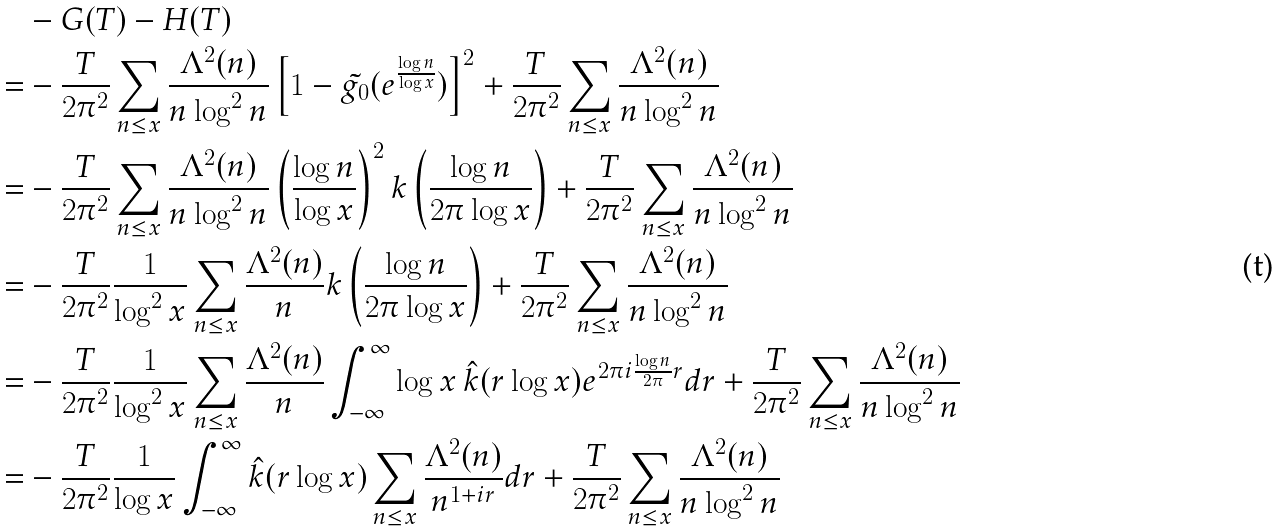<formula> <loc_0><loc_0><loc_500><loc_500>& - G ( T ) - H ( T ) \\ = & - \frac { T } { 2 \pi ^ { 2 } } \sum _ { n \leq x } \frac { \Lambda ^ { 2 } ( n ) } { n \log ^ { 2 } n } \left [ 1 - \tilde { g _ { 0 } } ( e ^ { \frac { \log n } { \log x } } ) \right ] ^ { 2 } + \frac { T } { 2 \pi ^ { 2 } } \sum _ { n \leq x } \frac { \Lambda ^ { 2 } ( n ) } { n \log ^ { 2 } n } \\ = & - \frac { T } { 2 \pi ^ { 2 } } \sum _ { n \leq x } \frac { \Lambda ^ { 2 } ( n ) } { n \log ^ { 2 } n } \left ( \frac { \log n } { \log x } \right ) ^ { 2 } k \left ( \frac { \log n } { 2 \pi \log x } \right ) + \frac { T } { 2 \pi ^ { 2 } } \sum _ { n \leq x } \frac { \Lambda ^ { 2 } ( n ) } { n \log ^ { 2 } n } \\ = & - \frac { T } { 2 \pi ^ { 2 } } \frac { 1 } { \log ^ { 2 } x } \sum _ { n \leq x } \frac { \Lambda ^ { 2 } ( n ) } { n } k \left ( \frac { \log n } { 2 \pi \log x } \right ) + \frac { T } { 2 \pi ^ { 2 } } \sum _ { n \leq x } \frac { \Lambda ^ { 2 } ( n ) } { n \log ^ { 2 } n } \\ = & - \frac { T } { 2 \pi ^ { 2 } } \frac { 1 } { \log ^ { 2 } x } \sum _ { n \leq x } \frac { \Lambda ^ { 2 } ( n ) } { n } \int _ { - \infty } ^ { \infty } \log x \, \hat { k } ( r \log x ) e ^ { 2 \pi i \frac { \log n } { 2 \pi } r } d r + \frac { T } { 2 \pi ^ { 2 } } \sum _ { n \leq x } \frac { \Lambda ^ { 2 } ( n ) } { n \log ^ { 2 } n } \\ = & - \frac { T } { 2 \pi ^ { 2 } } \frac { 1 } { \log x } \int _ { - \infty } ^ { \infty } \hat { k } ( r \log x ) \sum _ { n \leq x } \frac { \Lambda ^ { 2 } ( n ) } { n ^ { 1 + i r } } d r + \frac { T } { 2 \pi ^ { 2 } } \sum _ { n \leq x } \frac { \Lambda ^ { 2 } ( n ) } { n \log ^ { 2 } n }</formula> 